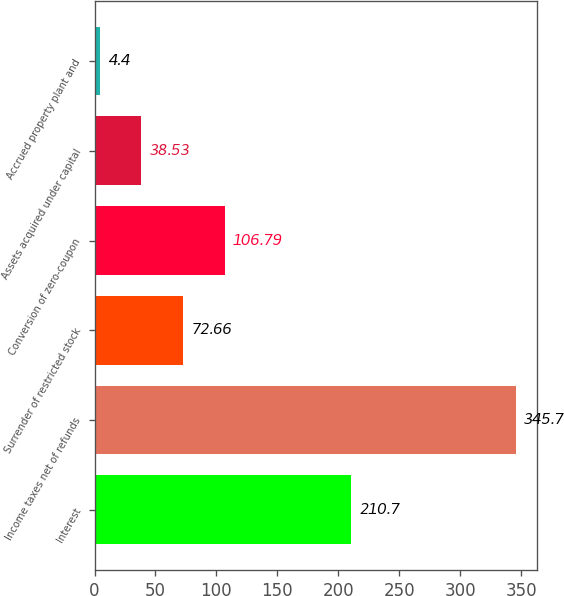Convert chart. <chart><loc_0><loc_0><loc_500><loc_500><bar_chart><fcel>Interest<fcel>Income taxes net of refunds<fcel>Surrender of restricted stock<fcel>Conversion of zero-coupon<fcel>Assets acquired under capital<fcel>Accrued property plant and<nl><fcel>210.7<fcel>345.7<fcel>72.66<fcel>106.79<fcel>38.53<fcel>4.4<nl></chart> 